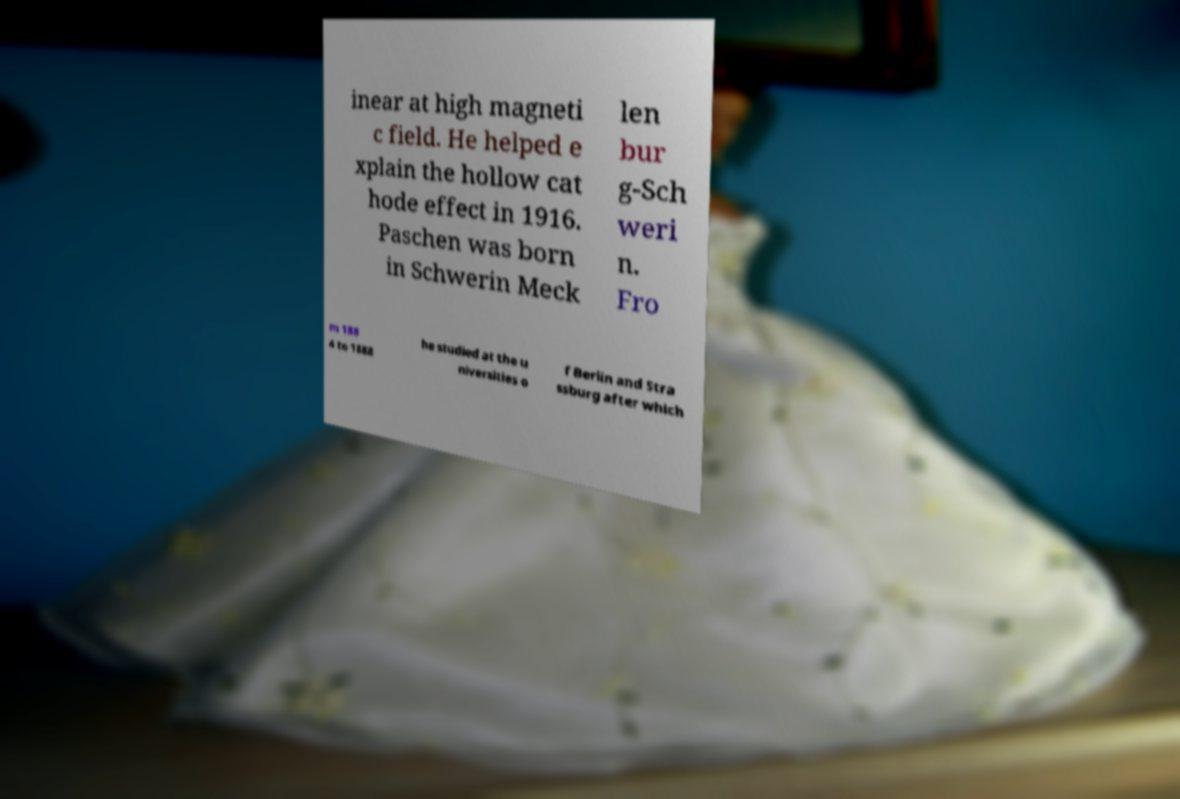What messages or text are displayed in this image? I need them in a readable, typed format. inear at high magneti c field. He helped e xplain the hollow cat hode effect in 1916. Paschen was born in Schwerin Meck len bur g-Sch weri n. Fro m 188 4 to 1888 he studied at the u niversities o f Berlin and Stra ssburg after which 